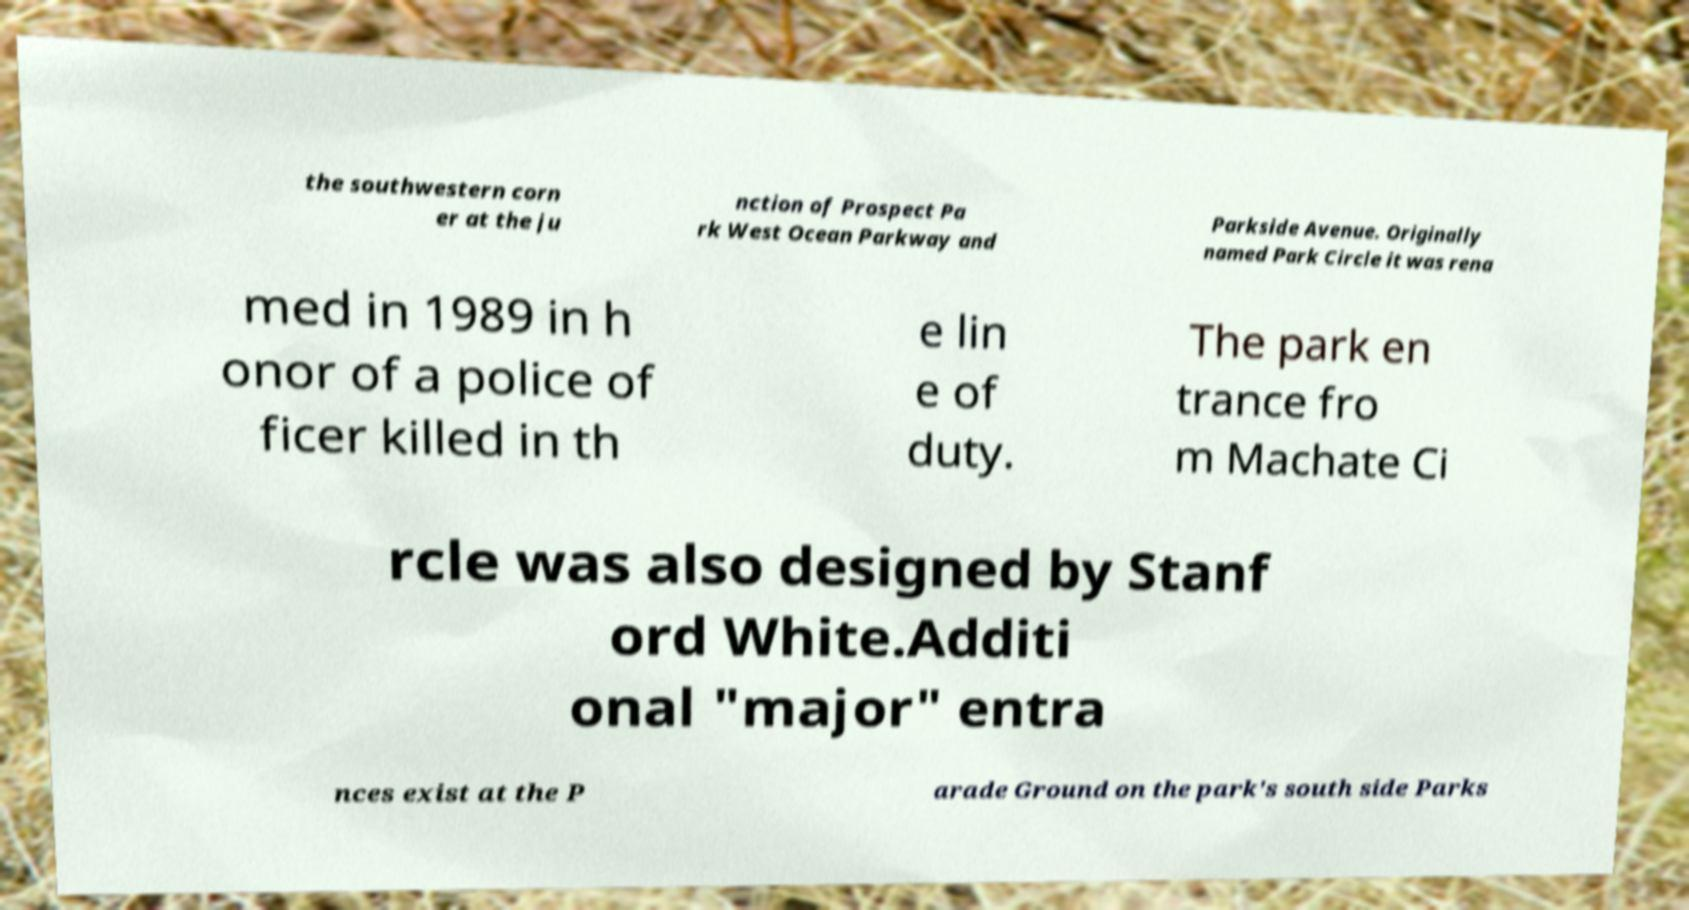I need the written content from this picture converted into text. Can you do that? the southwestern corn er at the ju nction of Prospect Pa rk West Ocean Parkway and Parkside Avenue. Originally named Park Circle it was rena med in 1989 in h onor of a police of ficer killed in th e lin e of duty. The park en trance fro m Machate Ci rcle was also designed by Stanf ord White.Additi onal "major" entra nces exist at the P arade Ground on the park's south side Parks 